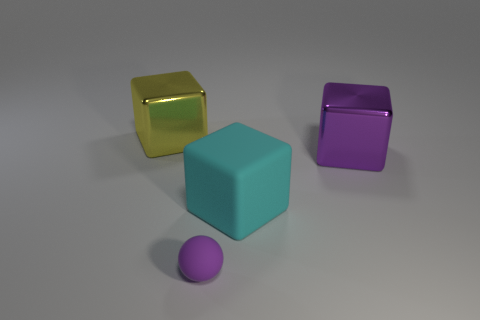Subtract all red balls. Subtract all red cubes. How many balls are left? 1 Add 3 purple cubes. How many objects exist? 7 Subtract all blocks. How many objects are left? 1 Subtract all large matte cylinders. Subtract all purple matte things. How many objects are left? 3 Add 2 big yellow cubes. How many big yellow cubes are left? 3 Add 3 tiny rubber balls. How many tiny rubber balls exist? 4 Subtract 1 purple balls. How many objects are left? 3 